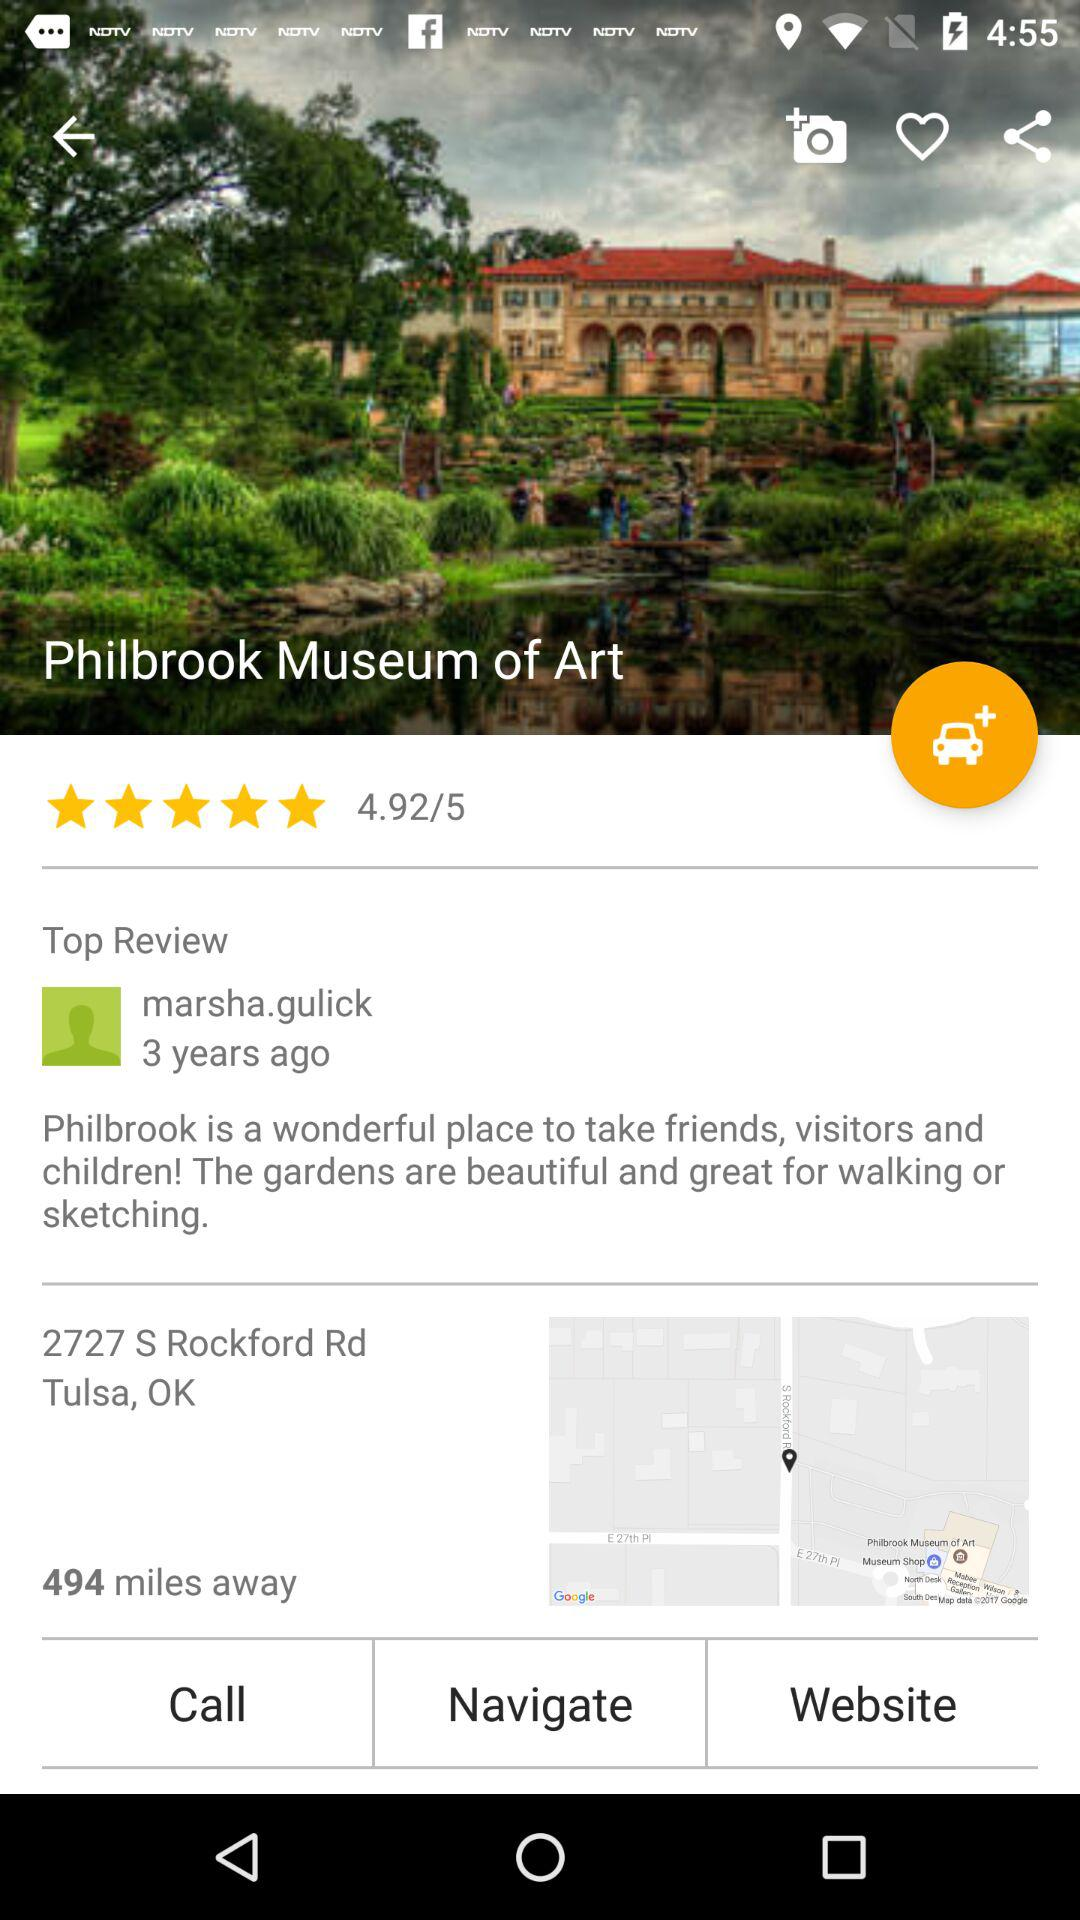When was the review given? The review was given 3 years ago. 